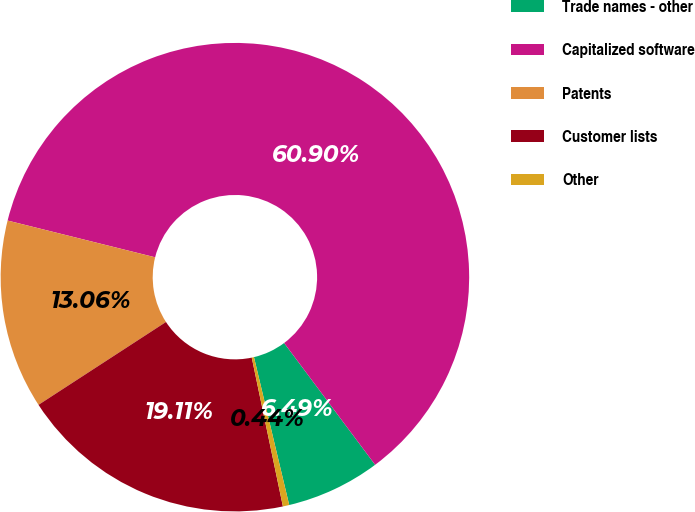Convert chart. <chart><loc_0><loc_0><loc_500><loc_500><pie_chart><fcel>Trade names - other<fcel>Capitalized software<fcel>Patents<fcel>Customer lists<fcel>Other<nl><fcel>6.49%<fcel>60.9%<fcel>13.06%<fcel>19.11%<fcel>0.44%<nl></chart> 